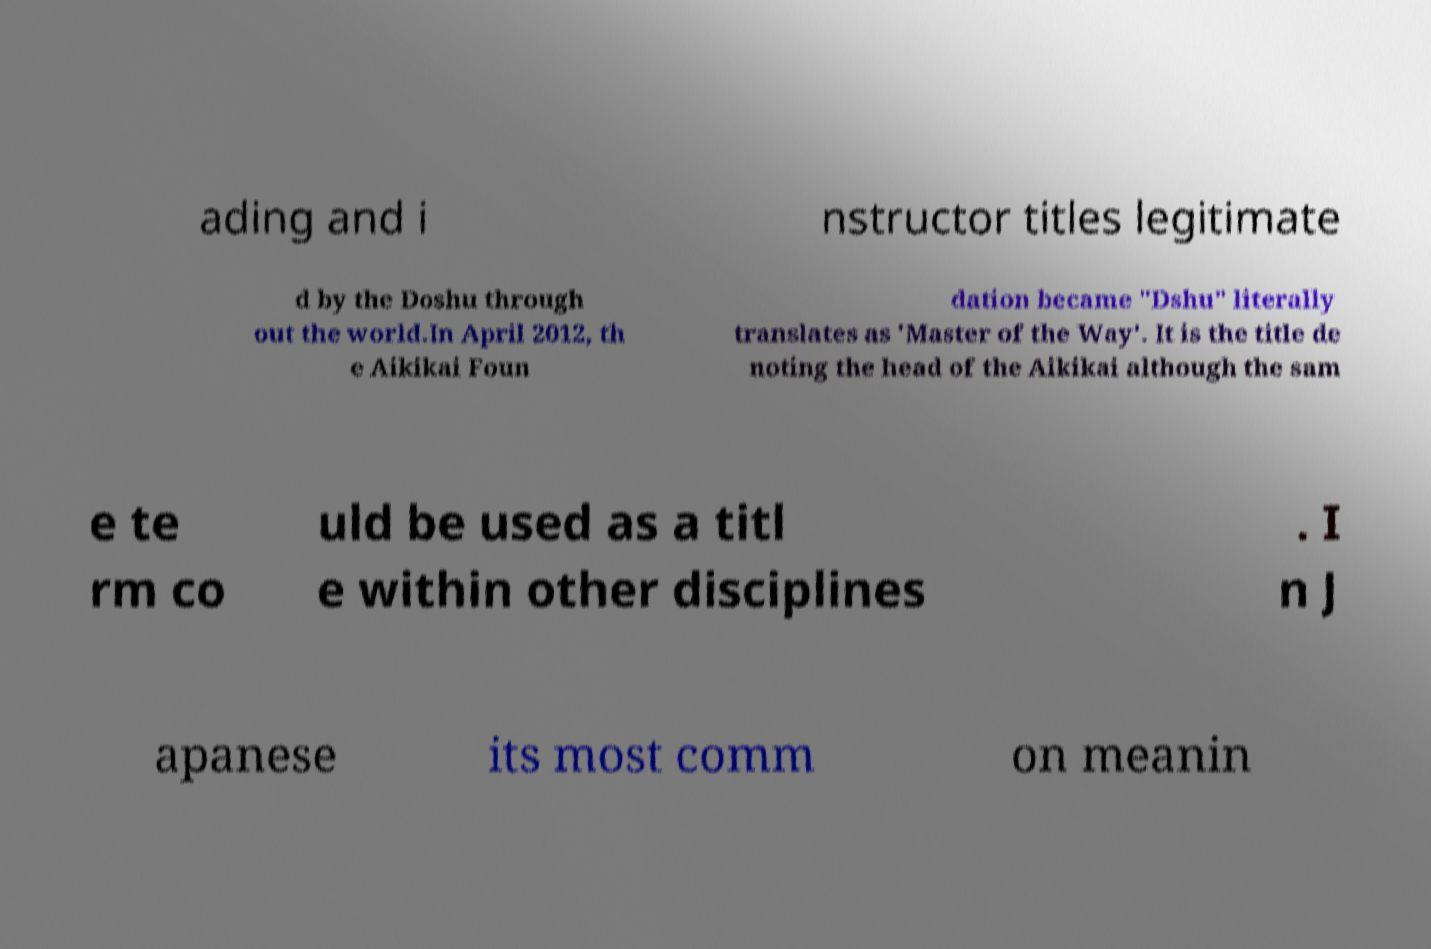There's text embedded in this image that I need extracted. Can you transcribe it verbatim? ading and i nstructor titles legitimate d by the Doshu through out the world.In April 2012, th e Aikikai Foun dation became "Dshu" literally translates as 'Master of the Way'. It is the title de noting the head of the Aikikai although the sam e te rm co uld be used as a titl e within other disciplines . I n J apanese its most comm on meanin 